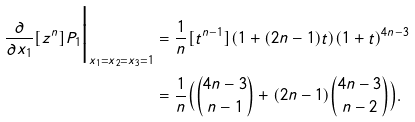Convert formula to latex. <formula><loc_0><loc_0><loc_500><loc_500>\frac { \partial } { \partial x _ { 1 } } [ z ^ { n } ] P _ { 1 } \Big | _ { x _ { 1 } = x _ { 2 } = x _ { 3 } = 1 } & = \frac { 1 } { n } [ t ^ { n - 1 } ] ( 1 + ( 2 n - 1 ) t ) ( 1 + t ) ^ { 4 n - 3 } \\ & = \frac { 1 } { n } \Big ( \binom { 4 n - 3 } { n - 1 } + ( 2 n - 1 ) \binom { 4 n - 3 } { n - 2 } \Big ) .</formula> 